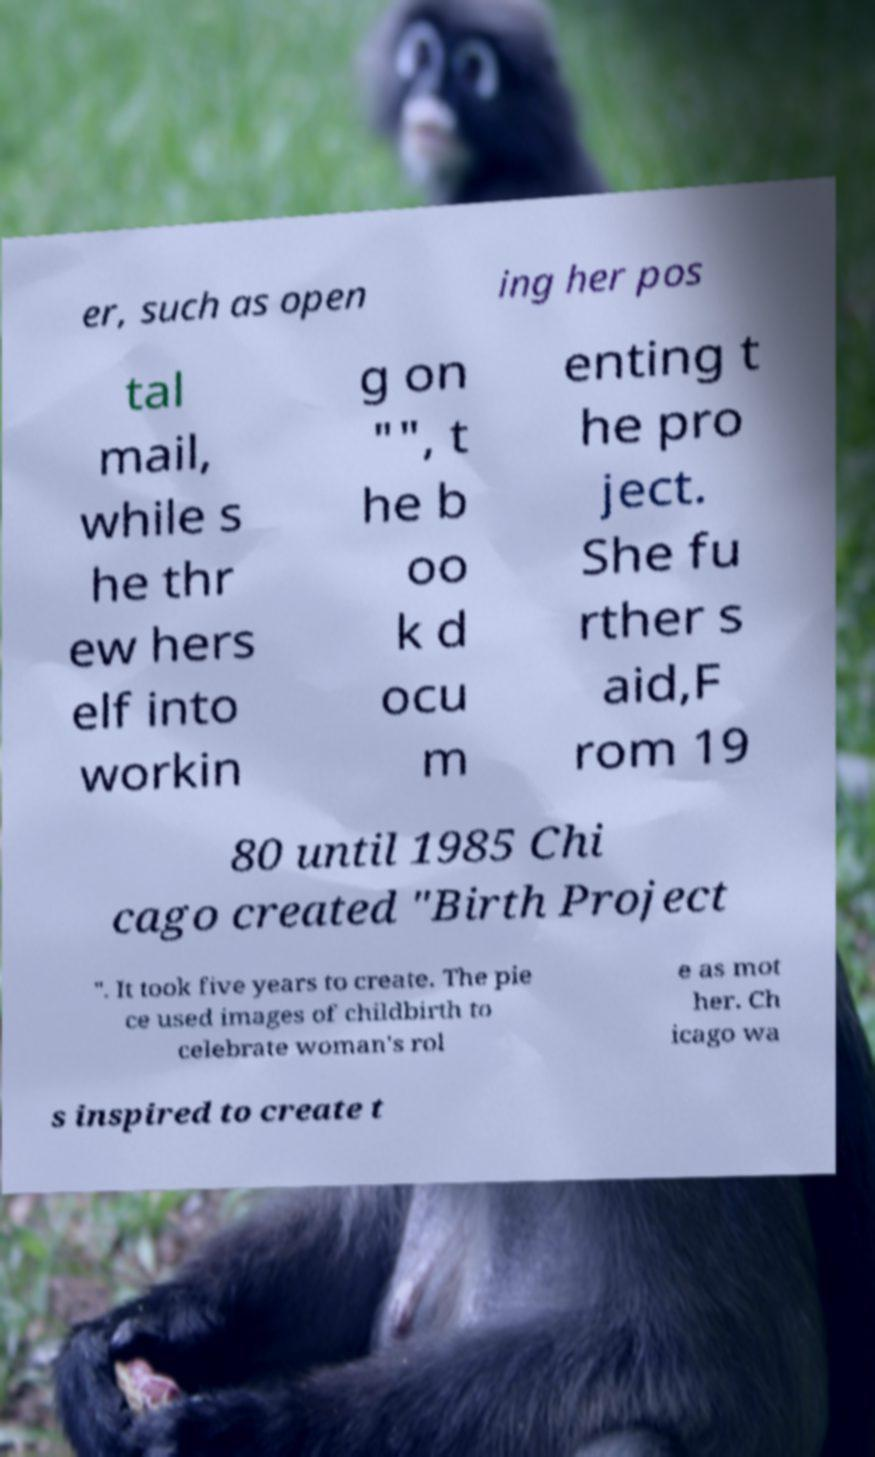What messages or text are displayed in this image? I need them in a readable, typed format. er, such as open ing her pos tal mail, while s he thr ew hers elf into workin g on "", t he b oo k d ocu m enting t he pro ject. She fu rther s aid,F rom 19 80 until 1985 Chi cago created "Birth Project ". It took five years to create. The pie ce used images of childbirth to celebrate woman's rol e as mot her. Ch icago wa s inspired to create t 